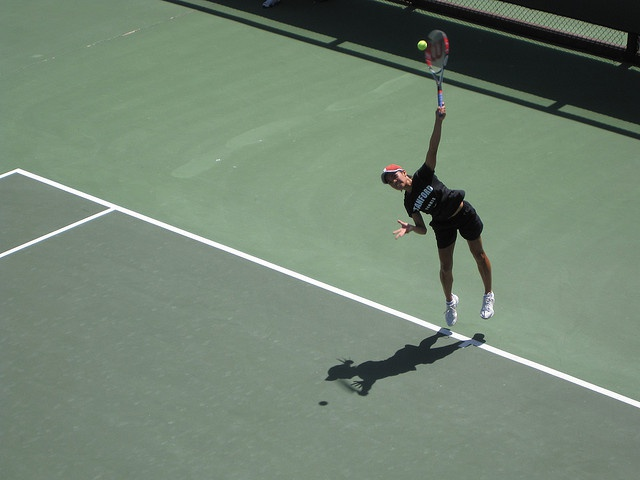Describe the objects in this image and their specific colors. I can see people in gray, black, and darkgray tones, tennis racket in gray, black, maroon, and purple tones, and sports ball in gray, green, and khaki tones in this image. 